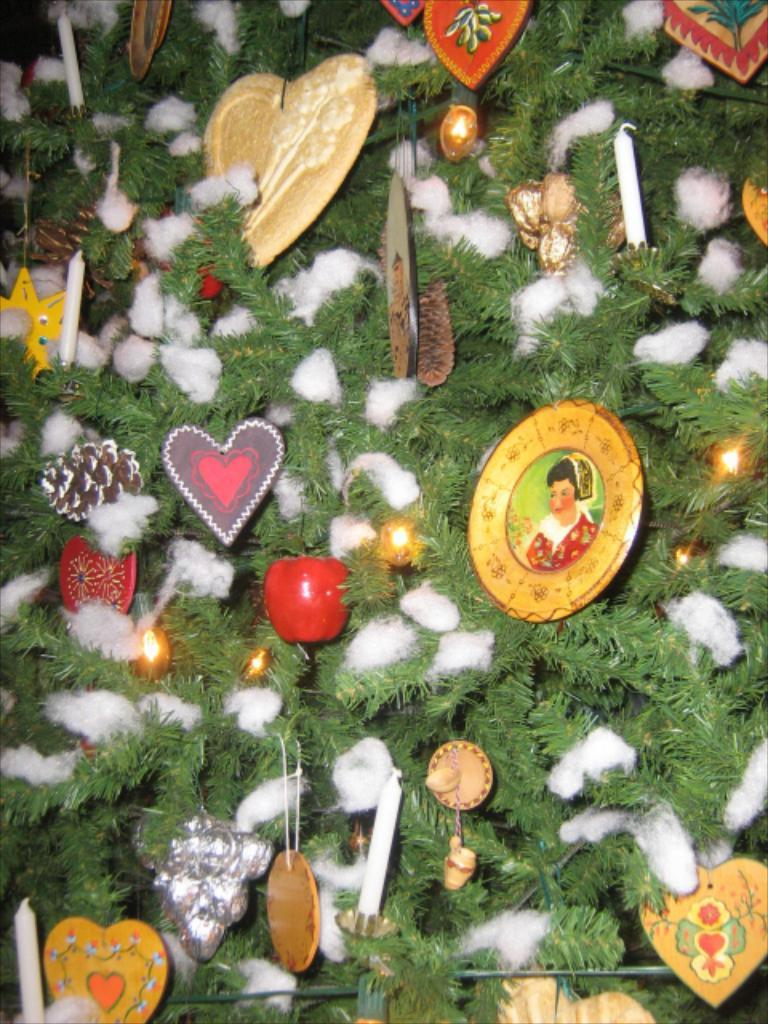What is the main subject of the image? The main subject of the image appears to be a Christmas tree. How is the Christmas tree decorated? The tree is decorated with various items. What material is present in the image? Cotton is present in the image. What type of fruit is hanging from the branches of the Christmas tree in the image? There is no fruit hanging from the branches of the Christmas tree in the image. 